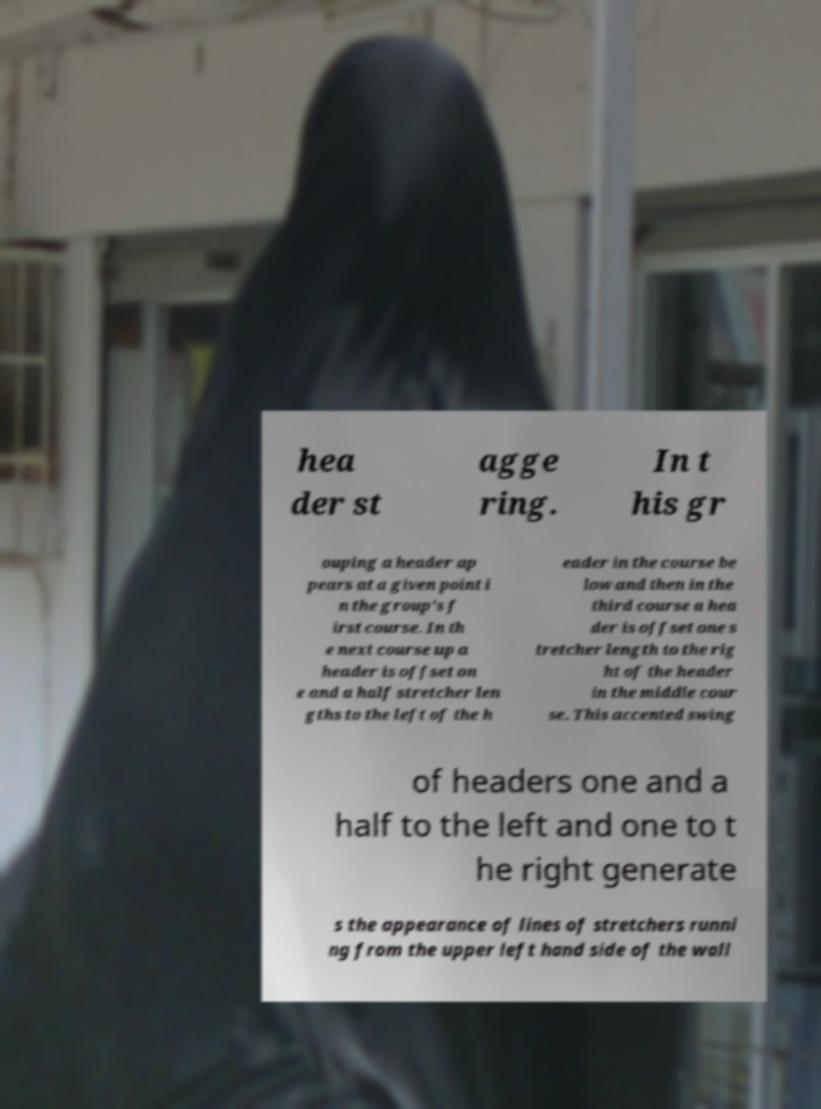I need the written content from this picture converted into text. Can you do that? hea der st agge ring. In t his gr ouping a header ap pears at a given point i n the group's f irst course. In th e next course up a header is offset on e and a half stretcher len gths to the left of the h eader in the course be low and then in the third course a hea der is offset one s tretcher length to the rig ht of the header in the middle cour se. This accented swing of headers one and a half to the left and one to t he right generate s the appearance of lines of stretchers runni ng from the upper left hand side of the wall 